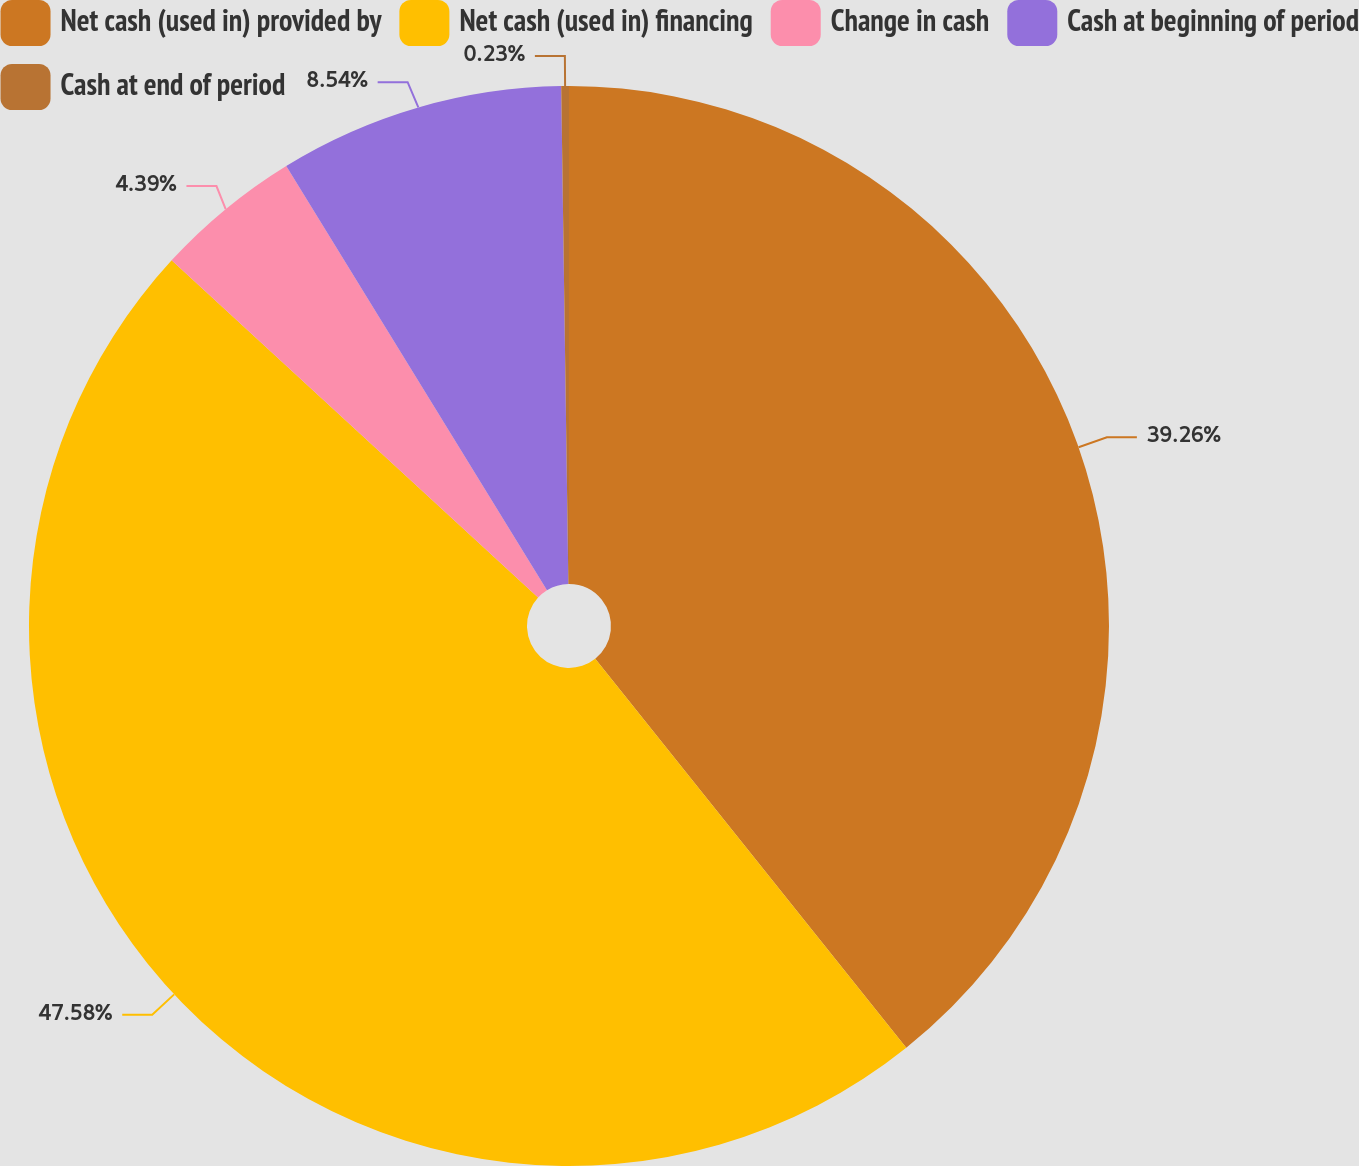Convert chart. <chart><loc_0><loc_0><loc_500><loc_500><pie_chart><fcel>Net cash (used in) provided by<fcel>Net cash (used in) financing<fcel>Change in cash<fcel>Cash at beginning of period<fcel>Cash at end of period<nl><fcel>39.26%<fcel>47.57%<fcel>4.39%<fcel>8.54%<fcel>0.23%<nl></chart> 